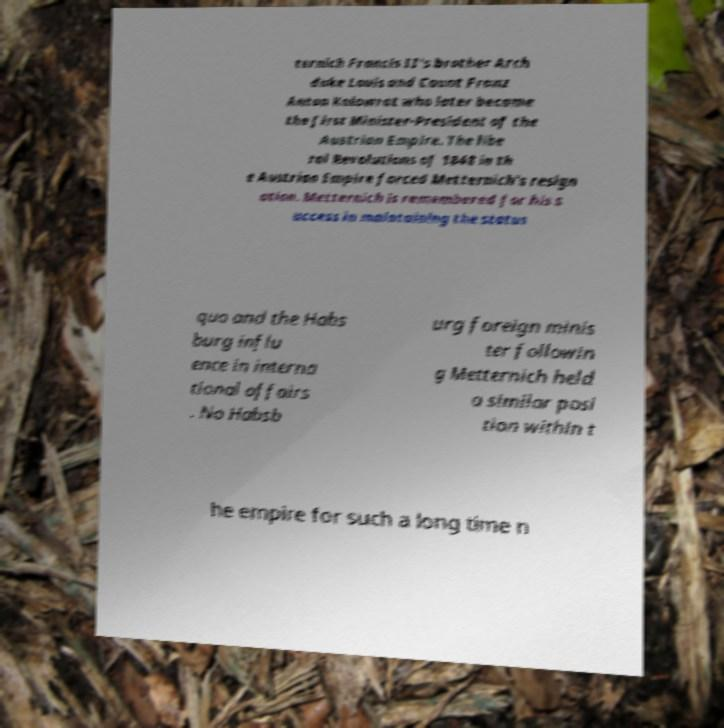I need the written content from this picture converted into text. Can you do that? ternich Francis II's brother Arch duke Louis and Count Franz Anton Kolowrat who later became the first Minister-President of the Austrian Empire. The libe ral Revolutions of 1848 in th e Austrian Empire forced Metternich's resign ation. Metternich is remembered for his s uccess in maintaining the status quo and the Habs burg influ ence in interna tional affairs . No Habsb urg foreign minis ter followin g Metternich held a similar posi tion within t he empire for such a long time n 